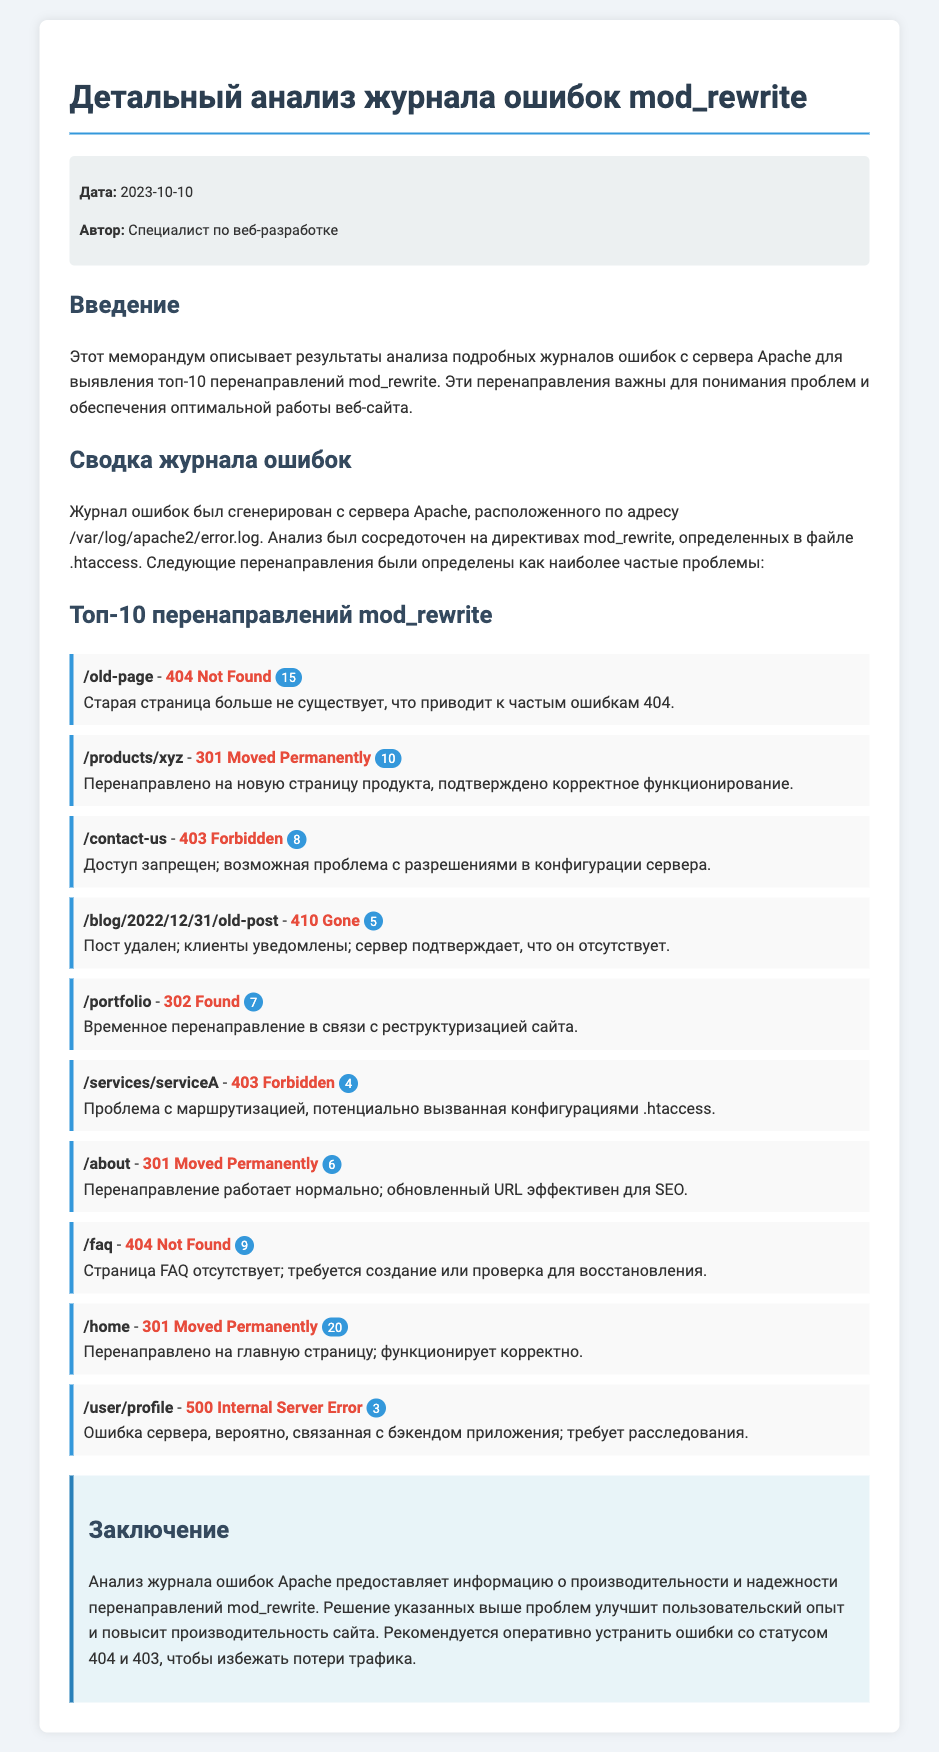что представляет собой этот меморандум? Меморандум описывает результаты анализа подробных журналов ошибок с сервера Apache для выявления топ-10 перенаправлений mod_rewrite.
Answer: анализ журналов ошибок какая дата создания документа? Дата создания документа указана в метаданных.
Answer: 2023-10-10 сколько перенаправлений имеет статус 404 Not Found? Общее количество перенаправлений со статусом 404 Not Found подсчитывается из списка.
Answer: 24 что означает статус 301? Статус 301 указывает на то, что ресурс был перенаправлен на другой URL.
Answer: Moved Permanently какая проблема с перенаправлением на /contact-us? Проблема с доступностью указана в журнале.
Answer: доступ запрещен какова основная проблема с URL /user/profile? Данная проблема связана с ошибкой на сервере.
Answer: 500 Internal Server Error сколько перенаправлений имеет статус 403 Forbidden? Число перенаправлений с этим статусом является результатом анализа.
Answer: 12 что рекомендуется в заключении документа? В заключении предлагается решить проблемы для улучшения работы сайта.
Answer: устранить ошибки на каком сервере были получены данные для анализа? Данные были получены с сервера Apache, расположенного в определенном месте.
Answer: /var/log/apache2/error.log 